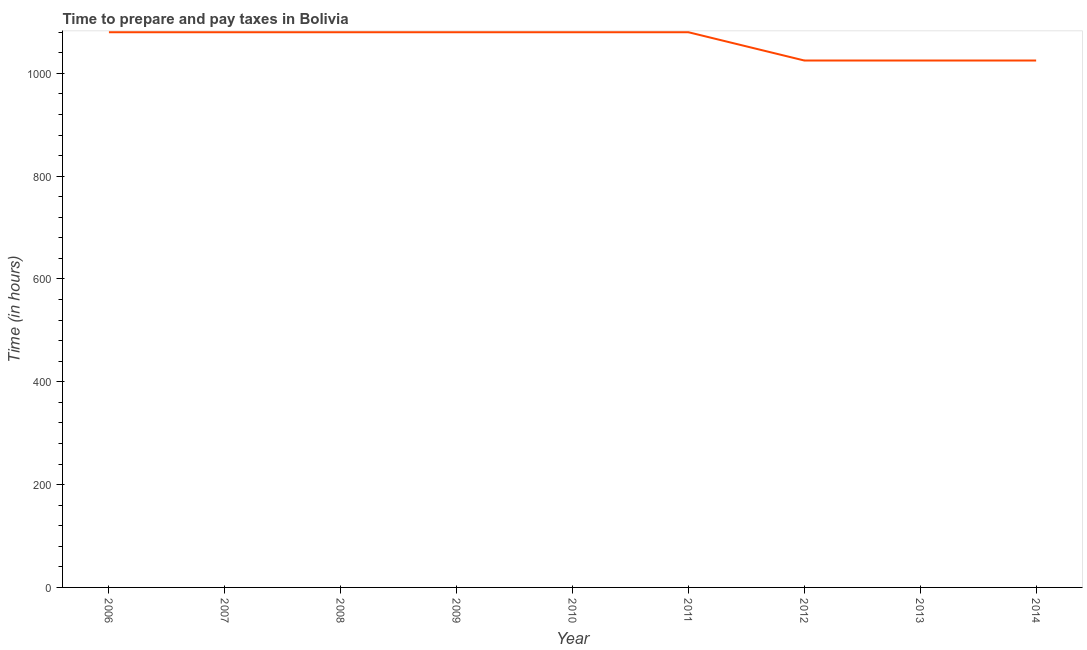What is the time to prepare and pay taxes in 2006?
Make the answer very short. 1080. Across all years, what is the maximum time to prepare and pay taxes?
Your answer should be very brief. 1080. Across all years, what is the minimum time to prepare and pay taxes?
Offer a very short reply. 1025. In which year was the time to prepare and pay taxes maximum?
Ensure brevity in your answer.  2006. What is the sum of the time to prepare and pay taxes?
Ensure brevity in your answer.  9555. What is the average time to prepare and pay taxes per year?
Make the answer very short. 1061.67. What is the median time to prepare and pay taxes?
Ensure brevity in your answer.  1080. What is the ratio of the time to prepare and pay taxes in 2011 to that in 2013?
Your answer should be compact. 1.05. Is the sum of the time to prepare and pay taxes in 2007 and 2012 greater than the maximum time to prepare and pay taxes across all years?
Offer a terse response. Yes. What is the difference between the highest and the lowest time to prepare and pay taxes?
Provide a short and direct response. 55. Does the time to prepare and pay taxes monotonically increase over the years?
Provide a short and direct response. No. How many years are there in the graph?
Provide a succinct answer. 9. Does the graph contain any zero values?
Your answer should be compact. No. What is the title of the graph?
Provide a succinct answer. Time to prepare and pay taxes in Bolivia. What is the label or title of the Y-axis?
Offer a very short reply. Time (in hours). What is the Time (in hours) of 2006?
Offer a very short reply. 1080. What is the Time (in hours) in 2007?
Keep it short and to the point. 1080. What is the Time (in hours) of 2008?
Keep it short and to the point. 1080. What is the Time (in hours) of 2009?
Keep it short and to the point. 1080. What is the Time (in hours) of 2010?
Provide a short and direct response. 1080. What is the Time (in hours) in 2011?
Give a very brief answer. 1080. What is the Time (in hours) of 2012?
Offer a very short reply. 1025. What is the Time (in hours) of 2013?
Your answer should be compact. 1025. What is the Time (in hours) of 2014?
Make the answer very short. 1025. What is the difference between the Time (in hours) in 2006 and 2008?
Keep it short and to the point. 0. What is the difference between the Time (in hours) in 2006 and 2010?
Offer a very short reply. 0. What is the difference between the Time (in hours) in 2006 and 2012?
Keep it short and to the point. 55. What is the difference between the Time (in hours) in 2007 and 2009?
Offer a very short reply. 0. What is the difference between the Time (in hours) in 2007 and 2010?
Your answer should be very brief. 0. What is the difference between the Time (in hours) in 2007 and 2013?
Your answer should be very brief. 55. What is the difference between the Time (in hours) in 2007 and 2014?
Make the answer very short. 55. What is the difference between the Time (in hours) in 2008 and 2009?
Your response must be concise. 0. What is the difference between the Time (in hours) in 2008 and 2011?
Provide a succinct answer. 0. What is the difference between the Time (in hours) in 2008 and 2014?
Offer a terse response. 55. What is the difference between the Time (in hours) in 2009 and 2010?
Ensure brevity in your answer.  0. What is the difference between the Time (in hours) in 2009 and 2013?
Your response must be concise. 55. What is the difference between the Time (in hours) in 2009 and 2014?
Offer a terse response. 55. What is the difference between the Time (in hours) in 2010 and 2012?
Keep it short and to the point. 55. What is the difference between the Time (in hours) in 2010 and 2013?
Offer a very short reply. 55. What is the difference between the Time (in hours) in 2011 and 2012?
Make the answer very short. 55. What is the difference between the Time (in hours) in 2011 and 2014?
Your response must be concise. 55. What is the ratio of the Time (in hours) in 2006 to that in 2008?
Your answer should be very brief. 1. What is the ratio of the Time (in hours) in 2006 to that in 2009?
Offer a very short reply. 1. What is the ratio of the Time (in hours) in 2006 to that in 2010?
Make the answer very short. 1. What is the ratio of the Time (in hours) in 2006 to that in 2011?
Keep it short and to the point. 1. What is the ratio of the Time (in hours) in 2006 to that in 2012?
Give a very brief answer. 1.05. What is the ratio of the Time (in hours) in 2006 to that in 2013?
Give a very brief answer. 1.05. What is the ratio of the Time (in hours) in 2006 to that in 2014?
Your response must be concise. 1.05. What is the ratio of the Time (in hours) in 2007 to that in 2008?
Your response must be concise. 1. What is the ratio of the Time (in hours) in 2007 to that in 2009?
Keep it short and to the point. 1. What is the ratio of the Time (in hours) in 2007 to that in 2012?
Provide a succinct answer. 1.05. What is the ratio of the Time (in hours) in 2007 to that in 2013?
Provide a succinct answer. 1.05. What is the ratio of the Time (in hours) in 2007 to that in 2014?
Provide a succinct answer. 1.05. What is the ratio of the Time (in hours) in 2008 to that in 2010?
Give a very brief answer. 1. What is the ratio of the Time (in hours) in 2008 to that in 2011?
Keep it short and to the point. 1. What is the ratio of the Time (in hours) in 2008 to that in 2012?
Offer a very short reply. 1.05. What is the ratio of the Time (in hours) in 2008 to that in 2013?
Offer a terse response. 1.05. What is the ratio of the Time (in hours) in 2008 to that in 2014?
Offer a terse response. 1.05. What is the ratio of the Time (in hours) in 2009 to that in 2011?
Provide a short and direct response. 1. What is the ratio of the Time (in hours) in 2009 to that in 2012?
Offer a very short reply. 1.05. What is the ratio of the Time (in hours) in 2009 to that in 2013?
Your answer should be compact. 1.05. What is the ratio of the Time (in hours) in 2009 to that in 2014?
Provide a short and direct response. 1.05. What is the ratio of the Time (in hours) in 2010 to that in 2012?
Your answer should be compact. 1.05. What is the ratio of the Time (in hours) in 2010 to that in 2013?
Offer a terse response. 1.05. What is the ratio of the Time (in hours) in 2010 to that in 2014?
Provide a succinct answer. 1.05. What is the ratio of the Time (in hours) in 2011 to that in 2012?
Make the answer very short. 1.05. What is the ratio of the Time (in hours) in 2011 to that in 2013?
Offer a very short reply. 1.05. What is the ratio of the Time (in hours) in 2011 to that in 2014?
Offer a very short reply. 1.05. What is the ratio of the Time (in hours) in 2012 to that in 2013?
Make the answer very short. 1. What is the ratio of the Time (in hours) in 2013 to that in 2014?
Your answer should be very brief. 1. 